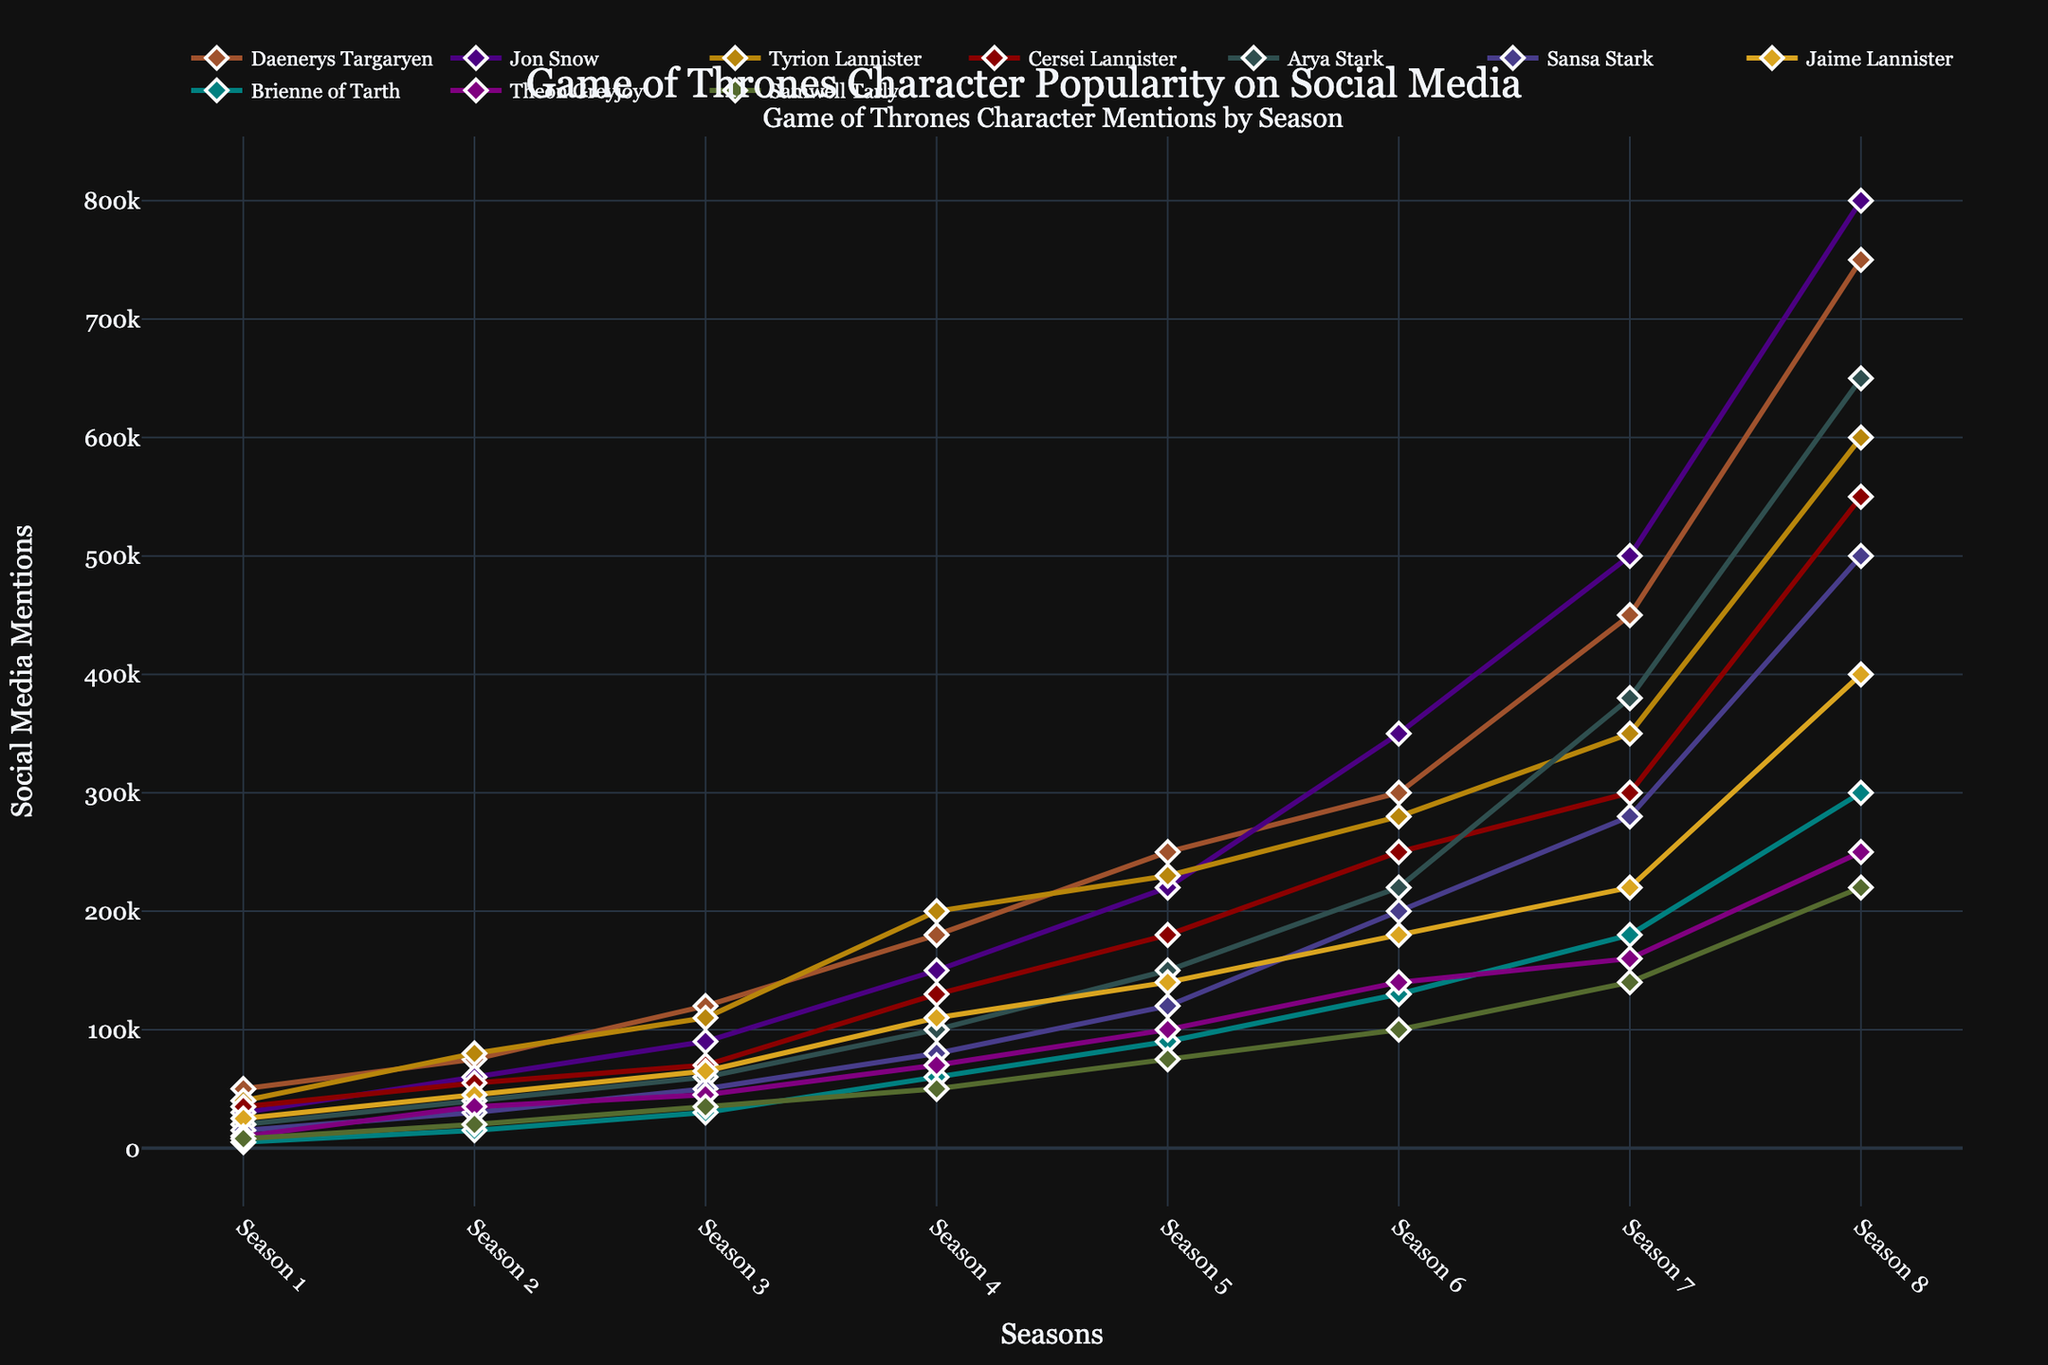Which character had the highest social media mentions in Season 8? Look at the points for Season 8 and identify the character with the highest y-value.
Answer: Jon Snow Compare the social media mentions of Daenerys Targaryen and Jon Snow in Season 4. Who had more mentions and by how much? Daenerys Targaryen had 180,000 mentions, and Jon Snow had 150,000 mentions in Season 4. 180,000 - 150,000 = 30,000.
Answer: Daenerys Targaryen by 30,000 Which characters had fewer than 100,000 social media mentions in Season 6? Identify characters whose points are below the 100,000 mark for Season 6.
Answer: Jaime Lannister, Theon Greyjoy, Samwell Tarly What is the average number of social media mentions for Arya Stark across all seasons? Add the number of mentions Arya Stark received in each season: 20,000 + 40,000 + 60,000 + 100,000 + 150,000 + 220,000 + 380,000 + 650,000 = 1,620,000. Divide by 8 seasons: 1,620,000 / 8 = 202,500.
Answer: 202,500 Which season showed the most increase in social media mentions for Tyrion Lannister and by how much? Compare the differences in mentions for each season. The largest increase is from Season 3 (110,000) to Season 4 (200,000): 200,000 - 110,000 = 90,000.
Answer: Season 4 by 90,000 Did Samwell Tarly have more mentions in Season 8 than Brienne of Tarth had in Season 5? Samwell Tarly had 220,000 mentions in Season 8, and Brienne of Tarth had 90,000 mentions in Season 5. 220,000 is greater than 90,000.
Answer: Yes Which two characters had the closest number of social media mentions in Season 5, and what is the difference? Daenerys Targaryen had 250,000 and Jon Snow had 220,000 mentions. The difference is 250,000 - 220,000 = 30,000.
Answer: Daenerys Targaryen and Jon Snow, 30,000 What is the total sum of social media mentions for Sansa Stark from Season 1 to Season 3? Sum the mentions for each season: 15,000 (Season 1) + 30,000 (Season 2) + 50,000 (Season 3) = 95,000.
Answer: 95,000 